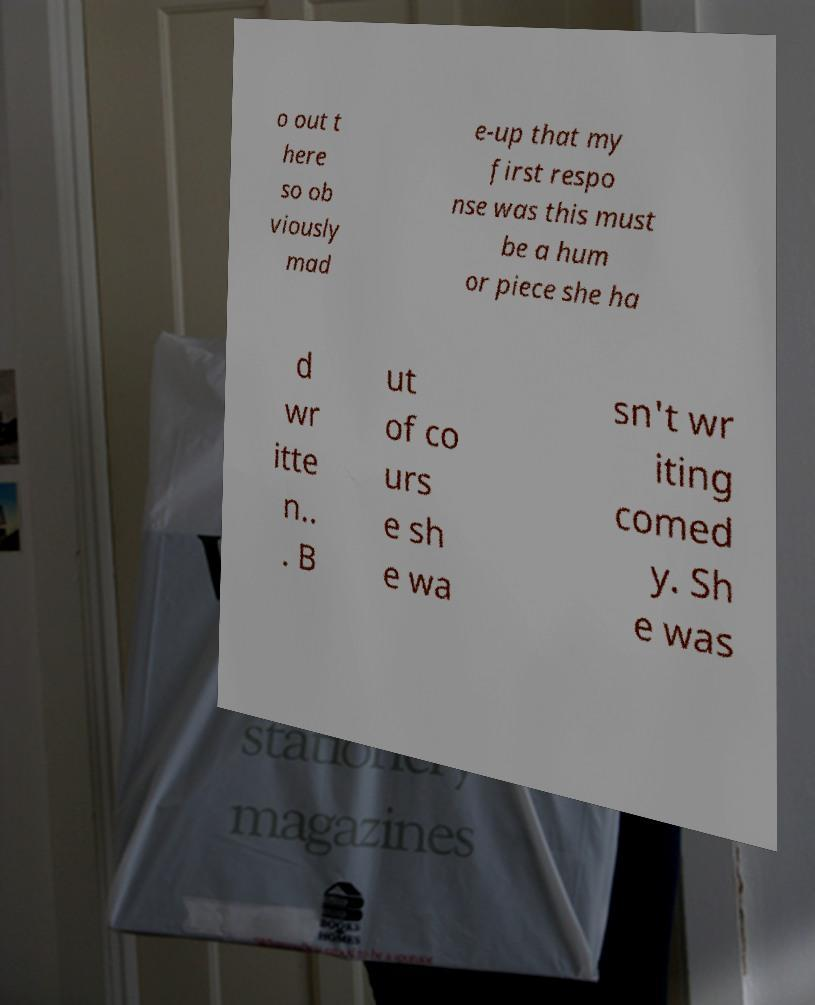Could you extract and type out the text from this image? o out t here so ob viously mad e-up that my first respo nse was this must be a hum or piece she ha d wr itte n.. . B ut of co urs e sh e wa sn't wr iting comed y. Sh e was 